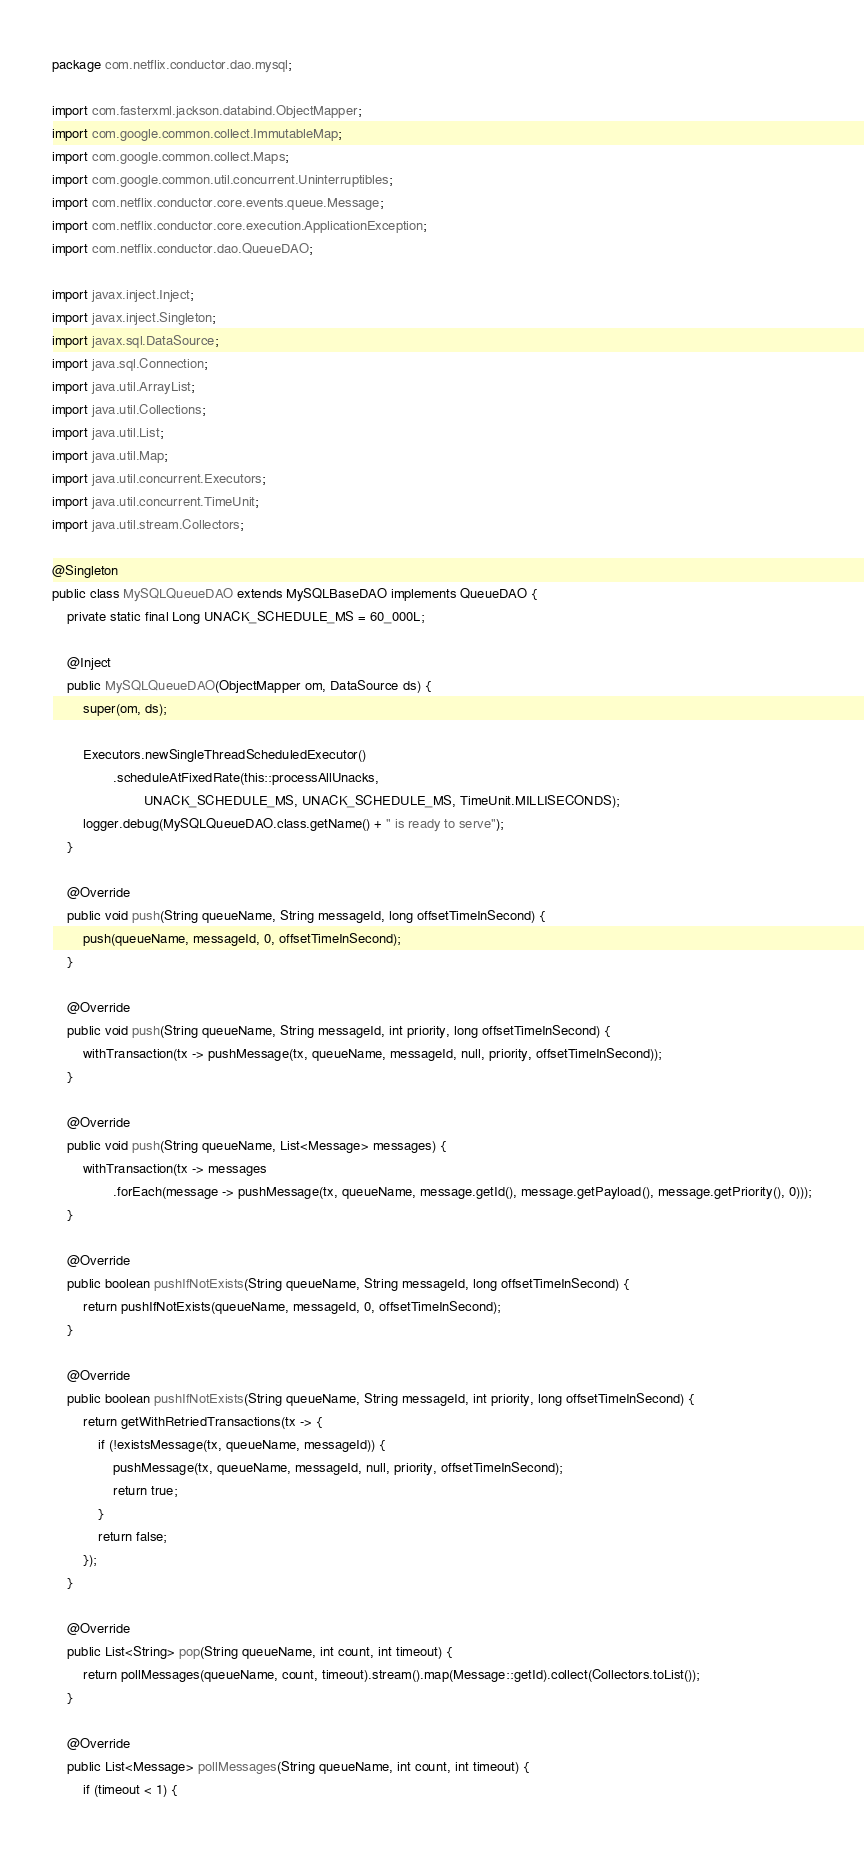<code> <loc_0><loc_0><loc_500><loc_500><_Java_>package com.netflix.conductor.dao.mysql;

import com.fasterxml.jackson.databind.ObjectMapper;
import com.google.common.collect.ImmutableMap;
import com.google.common.collect.Maps;
import com.google.common.util.concurrent.Uninterruptibles;
import com.netflix.conductor.core.events.queue.Message;
import com.netflix.conductor.core.execution.ApplicationException;
import com.netflix.conductor.dao.QueueDAO;

import javax.inject.Inject;
import javax.inject.Singleton;
import javax.sql.DataSource;
import java.sql.Connection;
import java.util.ArrayList;
import java.util.Collections;
import java.util.List;
import java.util.Map;
import java.util.concurrent.Executors;
import java.util.concurrent.TimeUnit;
import java.util.stream.Collectors;

@Singleton
public class MySQLQueueDAO extends MySQLBaseDAO implements QueueDAO {
    private static final Long UNACK_SCHEDULE_MS = 60_000L;

    @Inject
    public MySQLQueueDAO(ObjectMapper om, DataSource ds) {
        super(om, ds);

        Executors.newSingleThreadScheduledExecutor()
                .scheduleAtFixedRate(this::processAllUnacks,
                        UNACK_SCHEDULE_MS, UNACK_SCHEDULE_MS, TimeUnit.MILLISECONDS);
        logger.debug(MySQLQueueDAO.class.getName() + " is ready to serve");
    }

    @Override
    public void push(String queueName, String messageId, long offsetTimeInSecond) {
        push(queueName, messageId, 0, offsetTimeInSecond);
    }

    @Override
    public void push(String queueName, String messageId, int priority, long offsetTimeInSecond) {
        withTransaction(tx -> pushMessage(tx, queueName, messageId, null, priority, offsetTimeInSecond));
    }

    @Override
    public void push(String queueName, List<Message> messages) {
        withTransaction(tx -> messages
                .forEach(message -> pushMessage(tx, queueName, message.getId(), message.getPayload(), message.getPriority(), 0)));
    }

    @Override
    public boolean pushIfNotExists(String queueName, String messageId, long offsetTimeInSecond) {
        return pushIfNotExists(queueName, messageId, 0, offsetTimeInSecond);
    }

    @Override
    public boolean pushIfNotExists(String queueName, String messageId, int priority, long offsetTimeInSecond) {
        return getWithRetriedTransactions(tx -> {
            if (!existsMessage(tx, queueName, messageId)) {
                pushMessage(tx, queueName, messageId, null, priority, offsetTimeInSecond);
                return true;
            }
            return false;
        });
    }

    @Override
    public List<String> pop(String queueName, int count, int timeout) {
        return pollMessages(queueName, count, timeout).stream().map(Message::getId).collect(Collectors.toList());
    }

    @Override
    public List<Message> pollMessages(String queueName, int count, int timeout) {
        if (timeout < 1) {</code> 